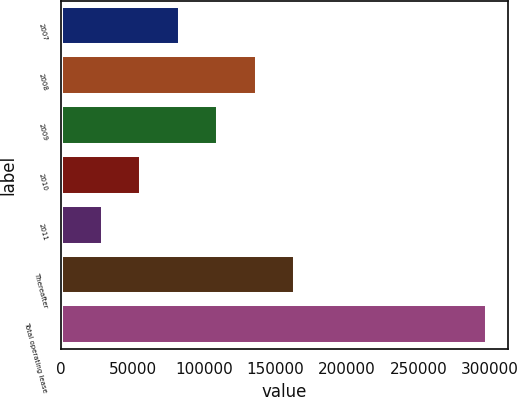Convert chart. <chart><loc_0><loc_0><loc_500><loc_500><bar_chart><fcel>2007<fcel>2008<fcel>2009<fcel>2010<fcel>2011<fcel>Thereafter<fcel>Total operating lease<nl><fcel>83050.2<fcel>136723<fcel>109887<fcel>56213.6<fcel>29377<fcel>163560<fcel>297743<nl></chart> 